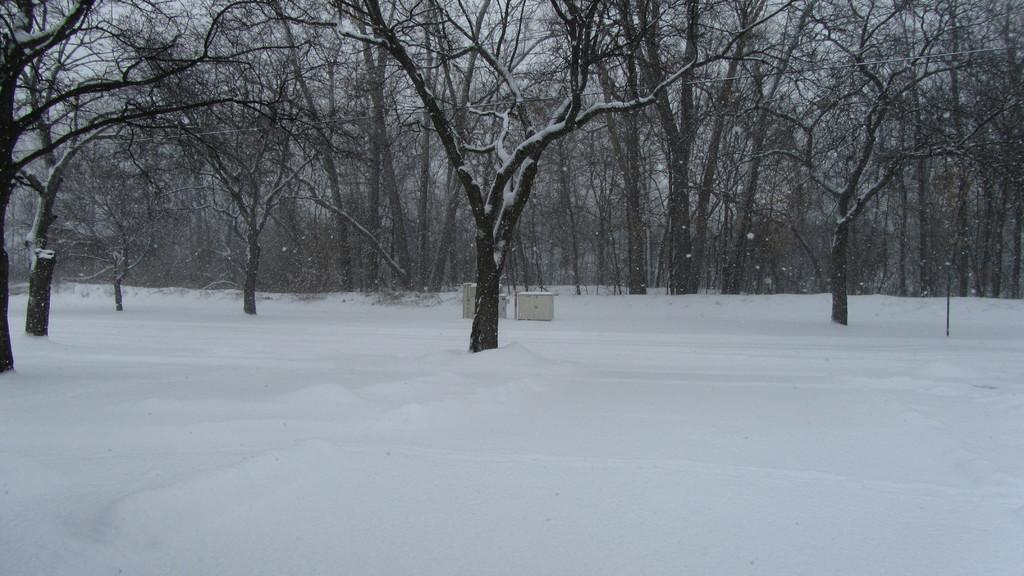What type of weather condition is depicted in the image? There is snow in the image, indicating a cold and wintry weather condition. What objects can be seen in the image besides the snow? There are boxes, a pole, and trees visible in the image. What is the background of the image? The sky is visible in the background of the image. What type of shade is provided by the trees in the image? There is no mention of shade in the image, as the trees are likely covered in snow and not providing shade. 